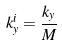<formula> <loc_0><loc_0><loc_500><loc_500>k _ { y } ^ { i } = \frac { k _ { y } } { M }</formula> 